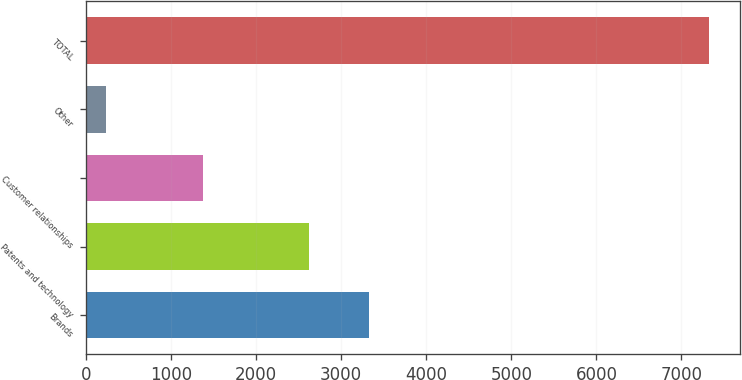<chart> <loc_0><loc_0><loc_500><loc_500><bar_chart><fcel>Brands<fcel>Patents and technology<fcel>Customer relationships<fcel>Other<fcel>TOTAL<nl><fcel>3325.8<fcel>2617<fcel>1377<fcel>239<fcel>7327<nl></chart> 